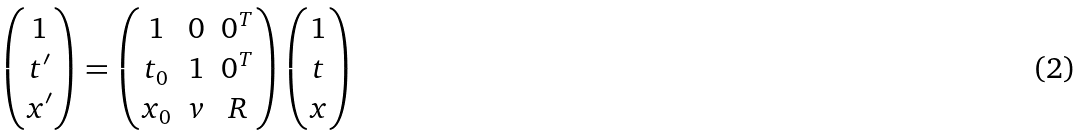Convert formula to latex. <formula><loc_0><loc_0><loc_500><loc_500>\begin{pmatrix} 1 \\ t ^ { \prime } \\ x ^ { \prime } \end{pmatrix} = \begin{pmatrix} 1 & 0 & 0 ^ { T } \\ t _ { 0 } & 1 & 0 ^ { T } \\ x _ { 0 } & v & R \end{pmatrix} \begin{pmatrix} 1 \\ t \\ x \end{pmatrix}</formula> 